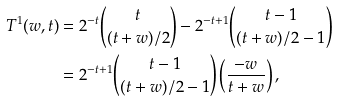<formula> <loc_0><loc_0><loc_500><loc_500>T ^ { 1 } ( w , t ) & = 2 ^ { - t } \binom { t } { ( t + w ) / 2 } - 2 ^ { - t + 1 } \binom { t - 1 } { ( t + w ) / 2 - 1 } \\ & = 2 ^ { - t + 1 } \binom { t - 1 } { ( t + w ) / 2 - 1 } \left ( \frac { - w } { t + w } \right ) ,</formula> 